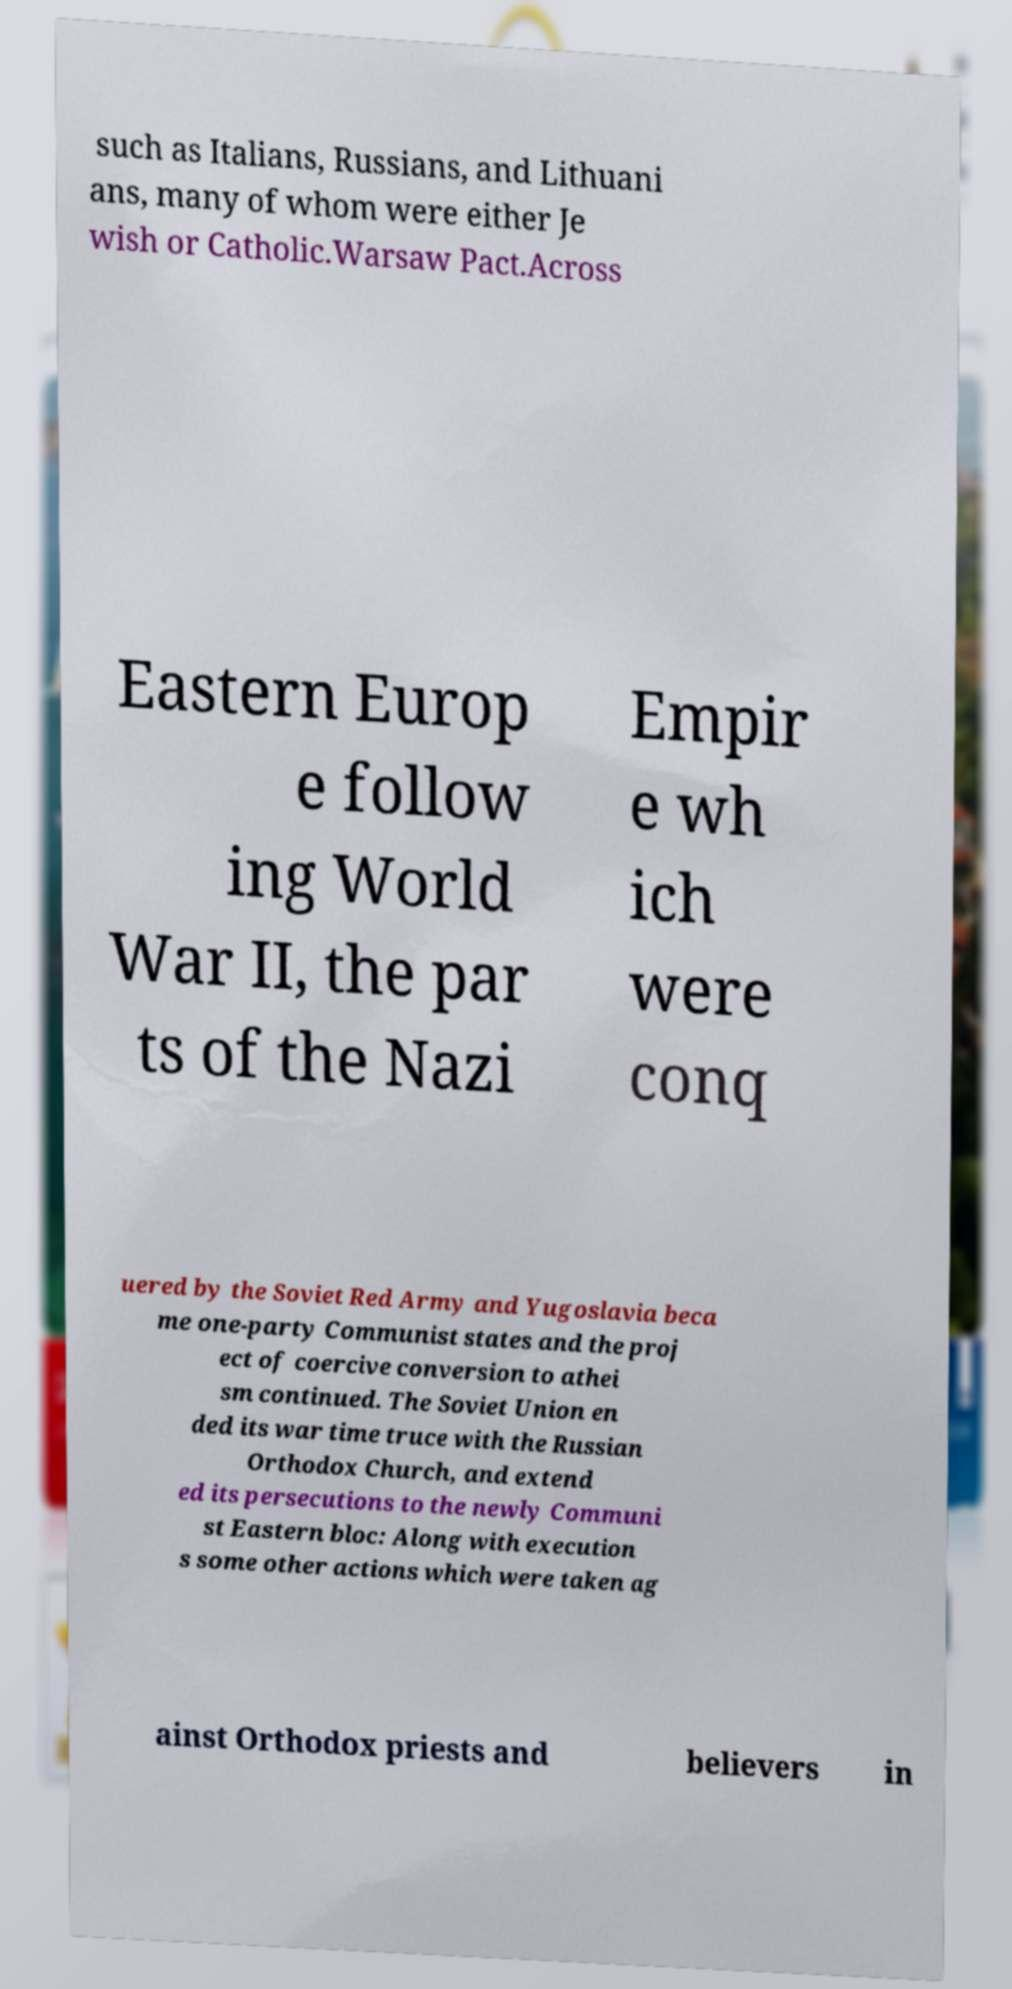For documentation purposes, I need the text within this image transcribed. Could you provide that? such as Italians, Russians, and Lithuani ans, many of whom were either Je wish or Catholic.Warsaw Pact.Across Eastern Europ e follow ing World War II, the par ts of the Nazi Empir e wh ich were conq uered by the Soviet Red Army and Yugoslavia beca me one-party Communist states and the proj ect of coercive conversion to athei sm continued. The Soviet Union en ded its war time truce with the Russian Orthodox Church, and extend ed its persecutions to the newly Communi st Eastern bloc: Along with execution s some other actions which were taken ag ainst Orthodox priests and believers in 